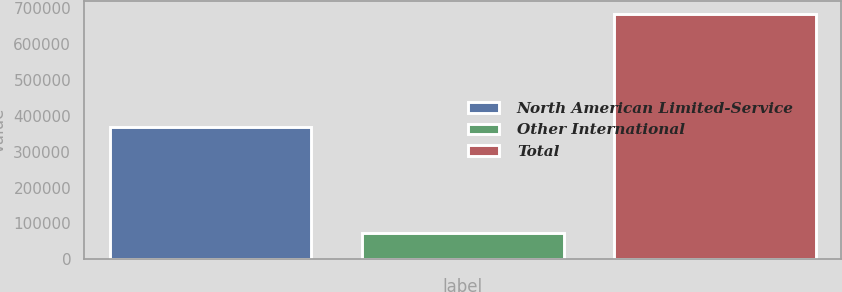<chart> <loc_0><loc_0><loc_500><loc_500><bar_chart><fcel>North American Limited-Service<fcel>Other International<fcel>Total<nl><fcel>369347<fcel>72866<fcel>685365<nl></chart> 